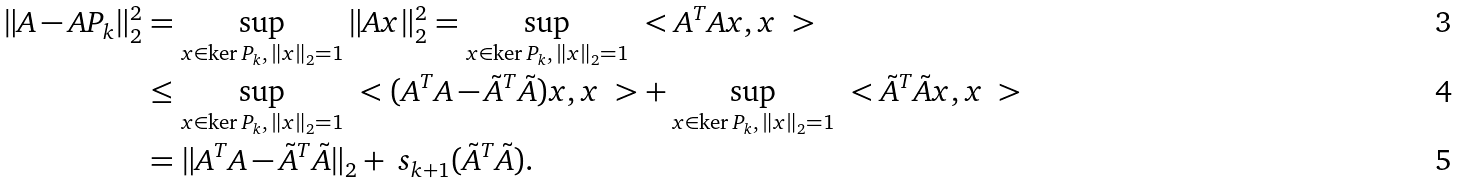<formula> <loc_0><loc_0><loc_500><loc_500>\| A - A P _ { k } \| _ { 2 } ^ { 2 } & = \sup _ { x \in \ker P _ { k } , \, \| x \| _ { 2 } = 1 } \| A x \| _ { 2 } ^ { 2 } = \sup _ { x \in \ker P _ { k } , \, \| x \| _ { 2 } = 1 } \ < A ^ { T } A x , x \ > \\ & \leq \sup _ { x \in \ker P _ { k } , \, \| x \| _ { 2 } = 1 } \ < ( A ^ { T } A - \tilde { A } ^ { T } \tilde { A } ) x , x \ > + \sup _ { x \in \ker P _ { k } , \, \| x \| _ { 2 } = 1 } \ < \tilde { A } ^ { T } \tilde { A } x , x \ > \\ & = \| A ^ { T } A - \tilde { A } ^ { T } \tilde { A } \| _ { 2 } + \ s _ { k + 1 } ( \tilde { A } ^ { T } \tilde { A } ) .</formula> 